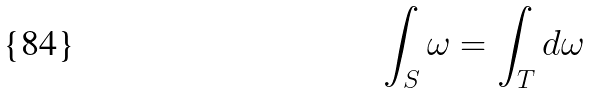<formula> <loc_0><loc_0><loc_500><loc_500>\int _ { S } \omega = \int _ { T } d \omega</formula> 